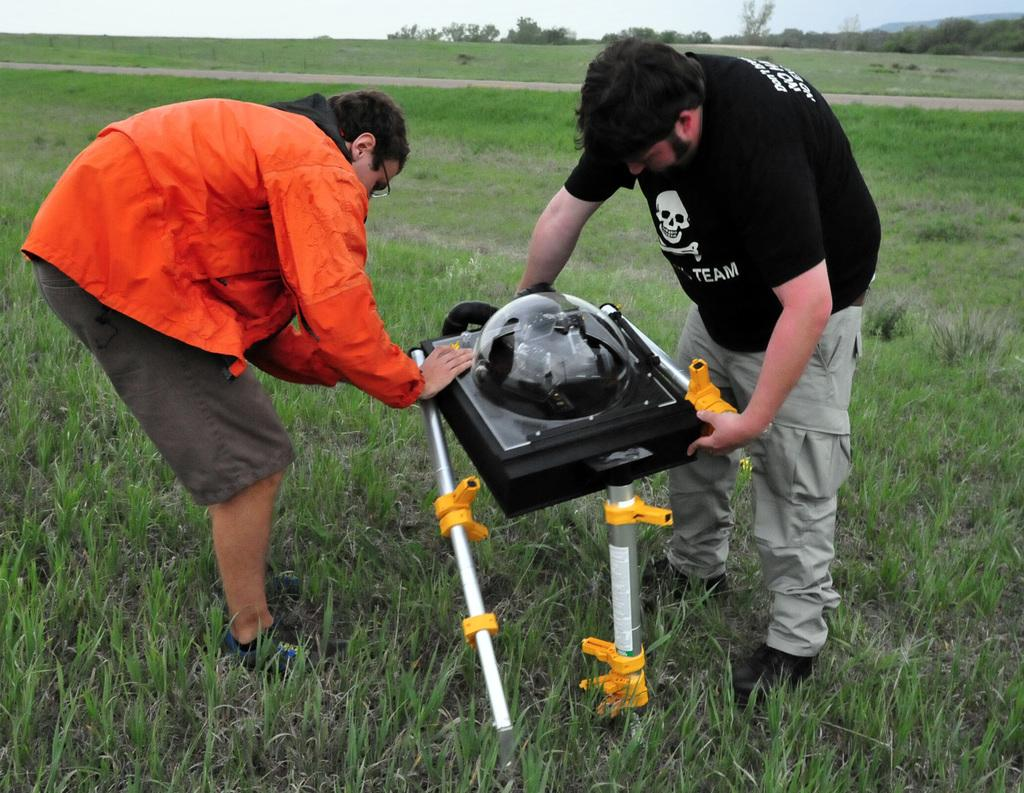How many people are in the image? There are two people standing in the image. What are the people holding in the image? The people are holding an object. What type of natural environment is visible in the image? There is grass visible in the image, and trees are in the background. What can be seen in the sky in the image? The sky is visible in the background of the image. What type of toothpaste is being used by the people in the image? There is no toothpaste present in the image; the people are holding an object, but it is not toothpaste. What suggestion is being made by the people in the image? There is no suggestion being made by the people in the image; they are simply holding an object. 